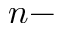<formula> <loc_0><loc_0><loc_500><loc_500>n -</formula> 